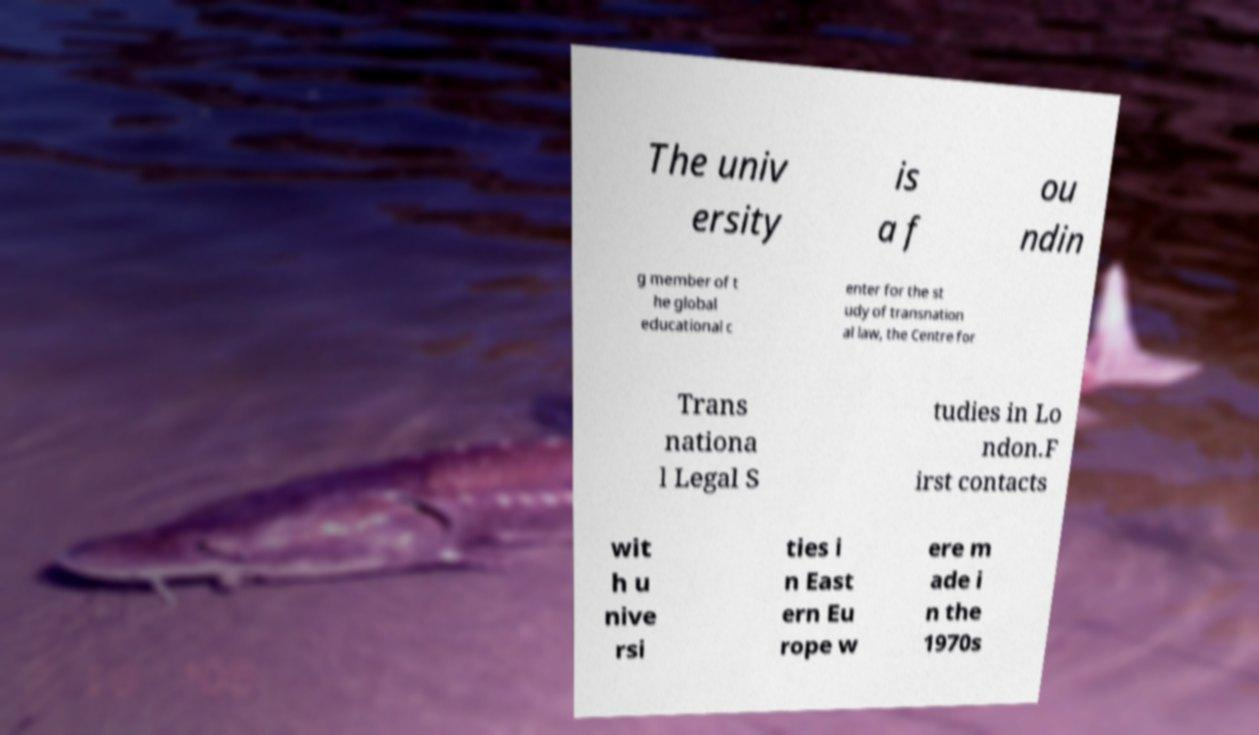Could you extract and type out the text from this image? The univ ersity is a f ou ndin g member of t he global educational c enter for the st udy of transnation al law, the Centre for Trans nationa l Legal S tudies in Lo ndon.F irst contacts wit h u nive rsi ties i n East ern Eu rope w ere m ade i n the 1970s 